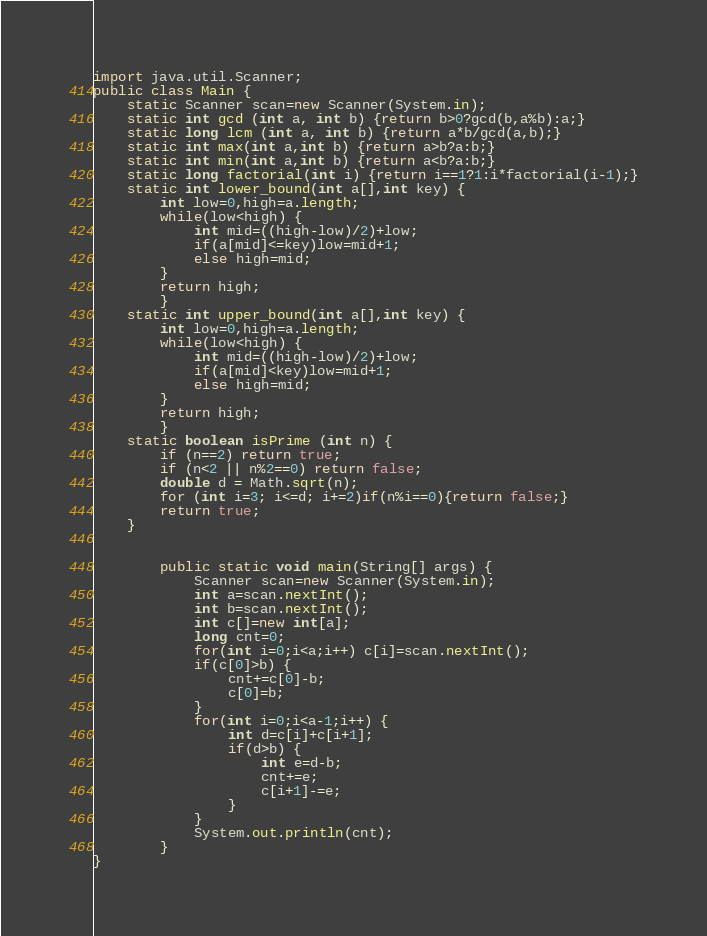<code> <loc_0><loc_0><loc_500><loc_500><_Java_>import java.util.Scanner;
public class Main {
	static Scanner scan=new Scanner(System.in);
	static int gcd (int a, int b) {return b>0?gcd(b,a%b):a;}
	static long lcm (int a, int b) {return a*b/gcd(a,b);}
	static int max(int a,int b) {return a>b?a:b;}
	static int min(int a,int b) {return a<b?a:b;}
	static long factorial(int i) {return i==1?1:i*factorial(i-1);}
	static int lower_bound(int a[],int key) {
		int low=0,high=a.length;
		while(low<high) {
			int mid=((high-low)/2)+low;
			if(a[mid]<=key)low=mid+1;
			else high=mid;
		}
		return high;
		}
	static int upper_bound(int a[],int key) {
		int low=0,high=a.length;
		while(low<high) {
			int mid=((high-low)/2)+low;
			if(a[mid]<key)low=mid+1;
			else high=mid;
		}
		return high;
		}
	static boolean isPrime (int n) {
		if (n==2) return true;
		if (n<2 || n%2==0) return false;
		double d = Math.sqrt(n);
		for (int i=3; i<=d; i+=2)if(n%i==0){return false;}
		return true;
	}


		public static void main(String[] args) {
			Scanner scan=new Scanner(System.in);
			int a=scan.nextInt();
			int b=scan.nextInt();
			int c[]=new int[a];
			long cnt=0;
			for(int i=0;i<a;i++) c[i]=scan.nextInt();
			if(c[0]>b) {
				cnt+=c[0]-b;
				c[0]=b;
			}
			for(int i=0;i<a-1;i++) {
				int d=c[i]+c[i+1];
				if(d>b) {
					int e=d-b;
					cnt+=e;
					c[i+1]-=e;
				}
			}
			System.out.println(cnt);
		}
}</code> 